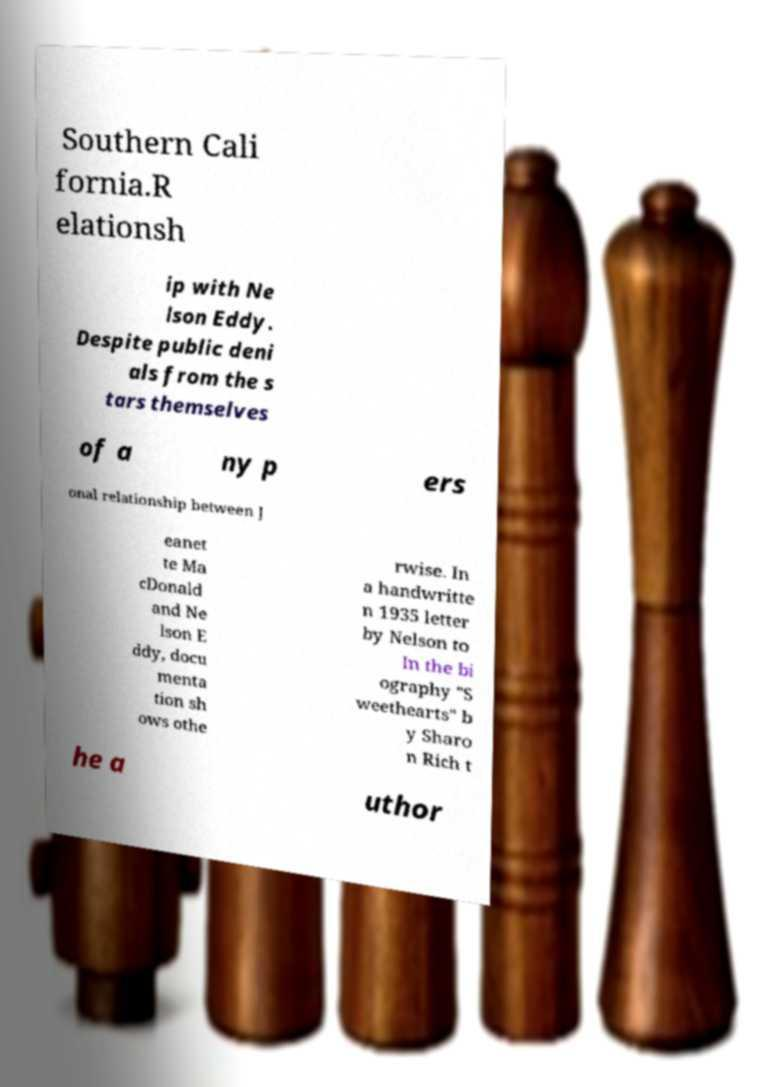Please read and relay the text visible in this image. What does it say? Southern Cali fornia.R elationsh ip with Ne lson Eddy. Despite public deni als from the s tars themselves of a ny p ers onal relationship between J eanet te Ma cDonald and Ne lson E ddy, docu menta tion sh ows othe rwise. In a handwritte n 1935 letter by Nelson to In the bi ography "S weethearts" b y Sharo n Rich t he a uthor 